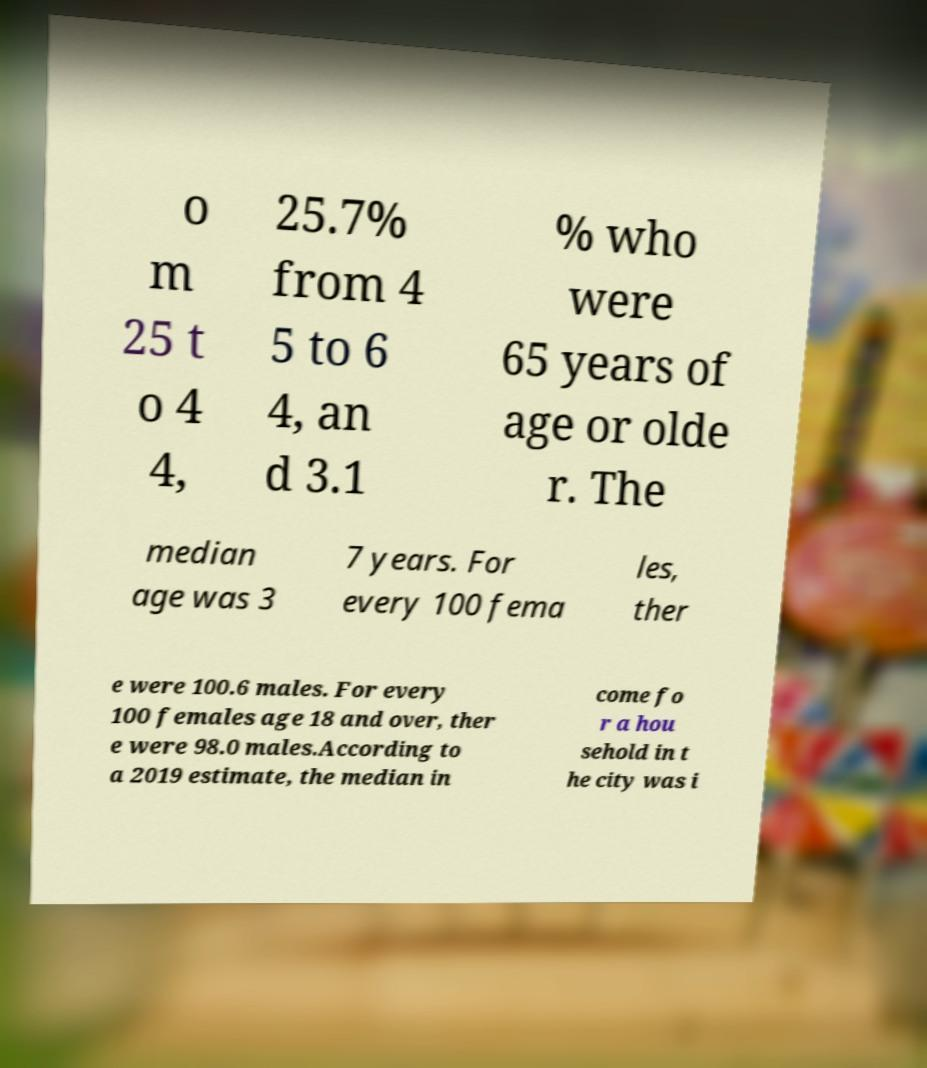For documentation purposes, I need the text within this image transcribed. Could you provide that? o m 25 t o 4 4, 25.7% from 4 5 to 6 4, an d 3.1 % who were 65 years of age or olde r. The median age was 3 7 years. For every 100 fema les, ther e were 100.6 males. For every 100 females age 18 and over, ther e were 98.0 males.According to a 2019 estimate, the median in come fo r a hou sehold in t he city was i 